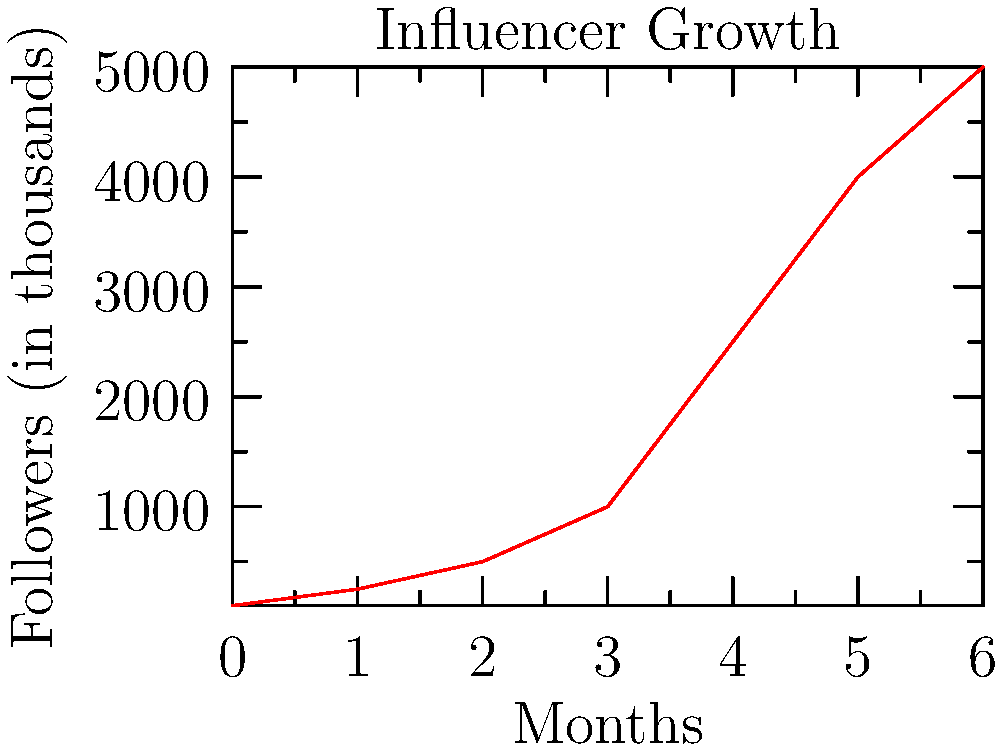Based on the graph showing your follower growth over the past 6 months, what was the approximate percentage increase in your following from month 3 to month 4? To calculate the percentage increase from month 3 to month 4:

1. Identify follower count at month 3: 1,000,000
2. Identify follower count at month 4: 2,500,000
3. Calculate the difference: 2,500,000 - 1,000,000 = 1,500,000
4. Divide the difference by the initial value: 1,500,000 / 1,000,000 = 1.5
5. Convert to percentage: 1.5 * 100 = 150%

The calculation can be expressed as:

$$ \text{Percentage Increase} = \frac{\text{New Value} - \text{Original Value}}{\text{Original Value}} \times 100\% $$

$$ = \frac{2,500,000 - 1,000,000}{1,000,000} \times 100\% = 150\% $$
Answer: 150% 